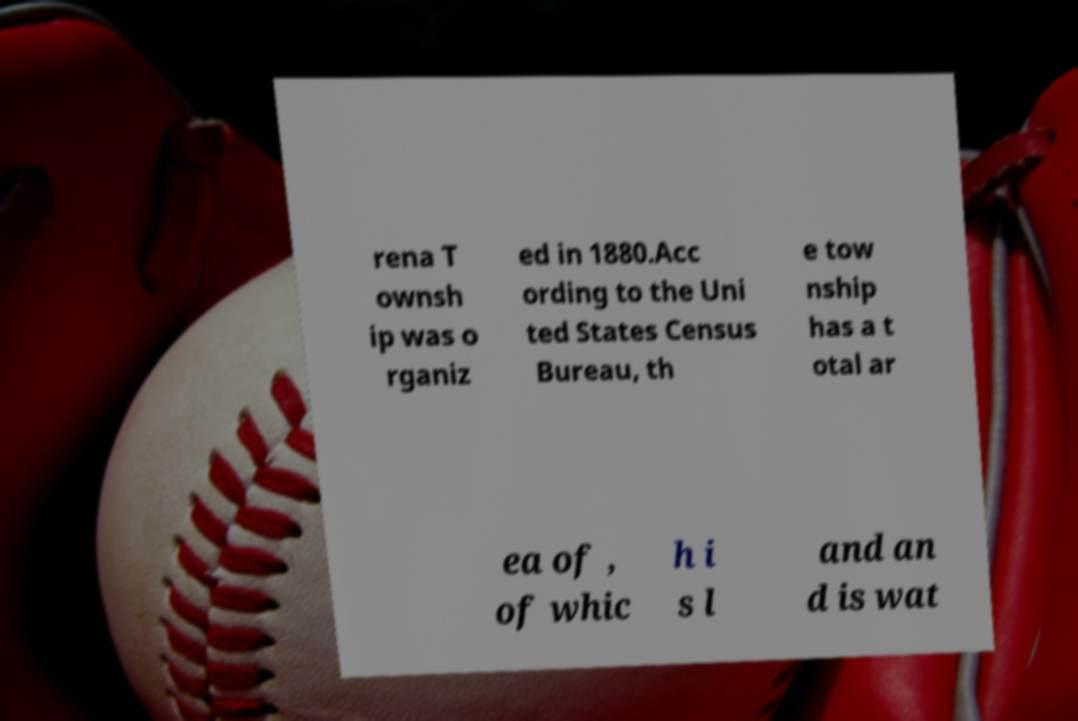Can you accurately transcribe the text from the provided image for me? rena T ownsh ip was o rganiz ed in 1880.Acc ording to the Uni ted States Census Bureau, th e tow nship has a t otal ar ea of , of whic h i s l and an d is wat 